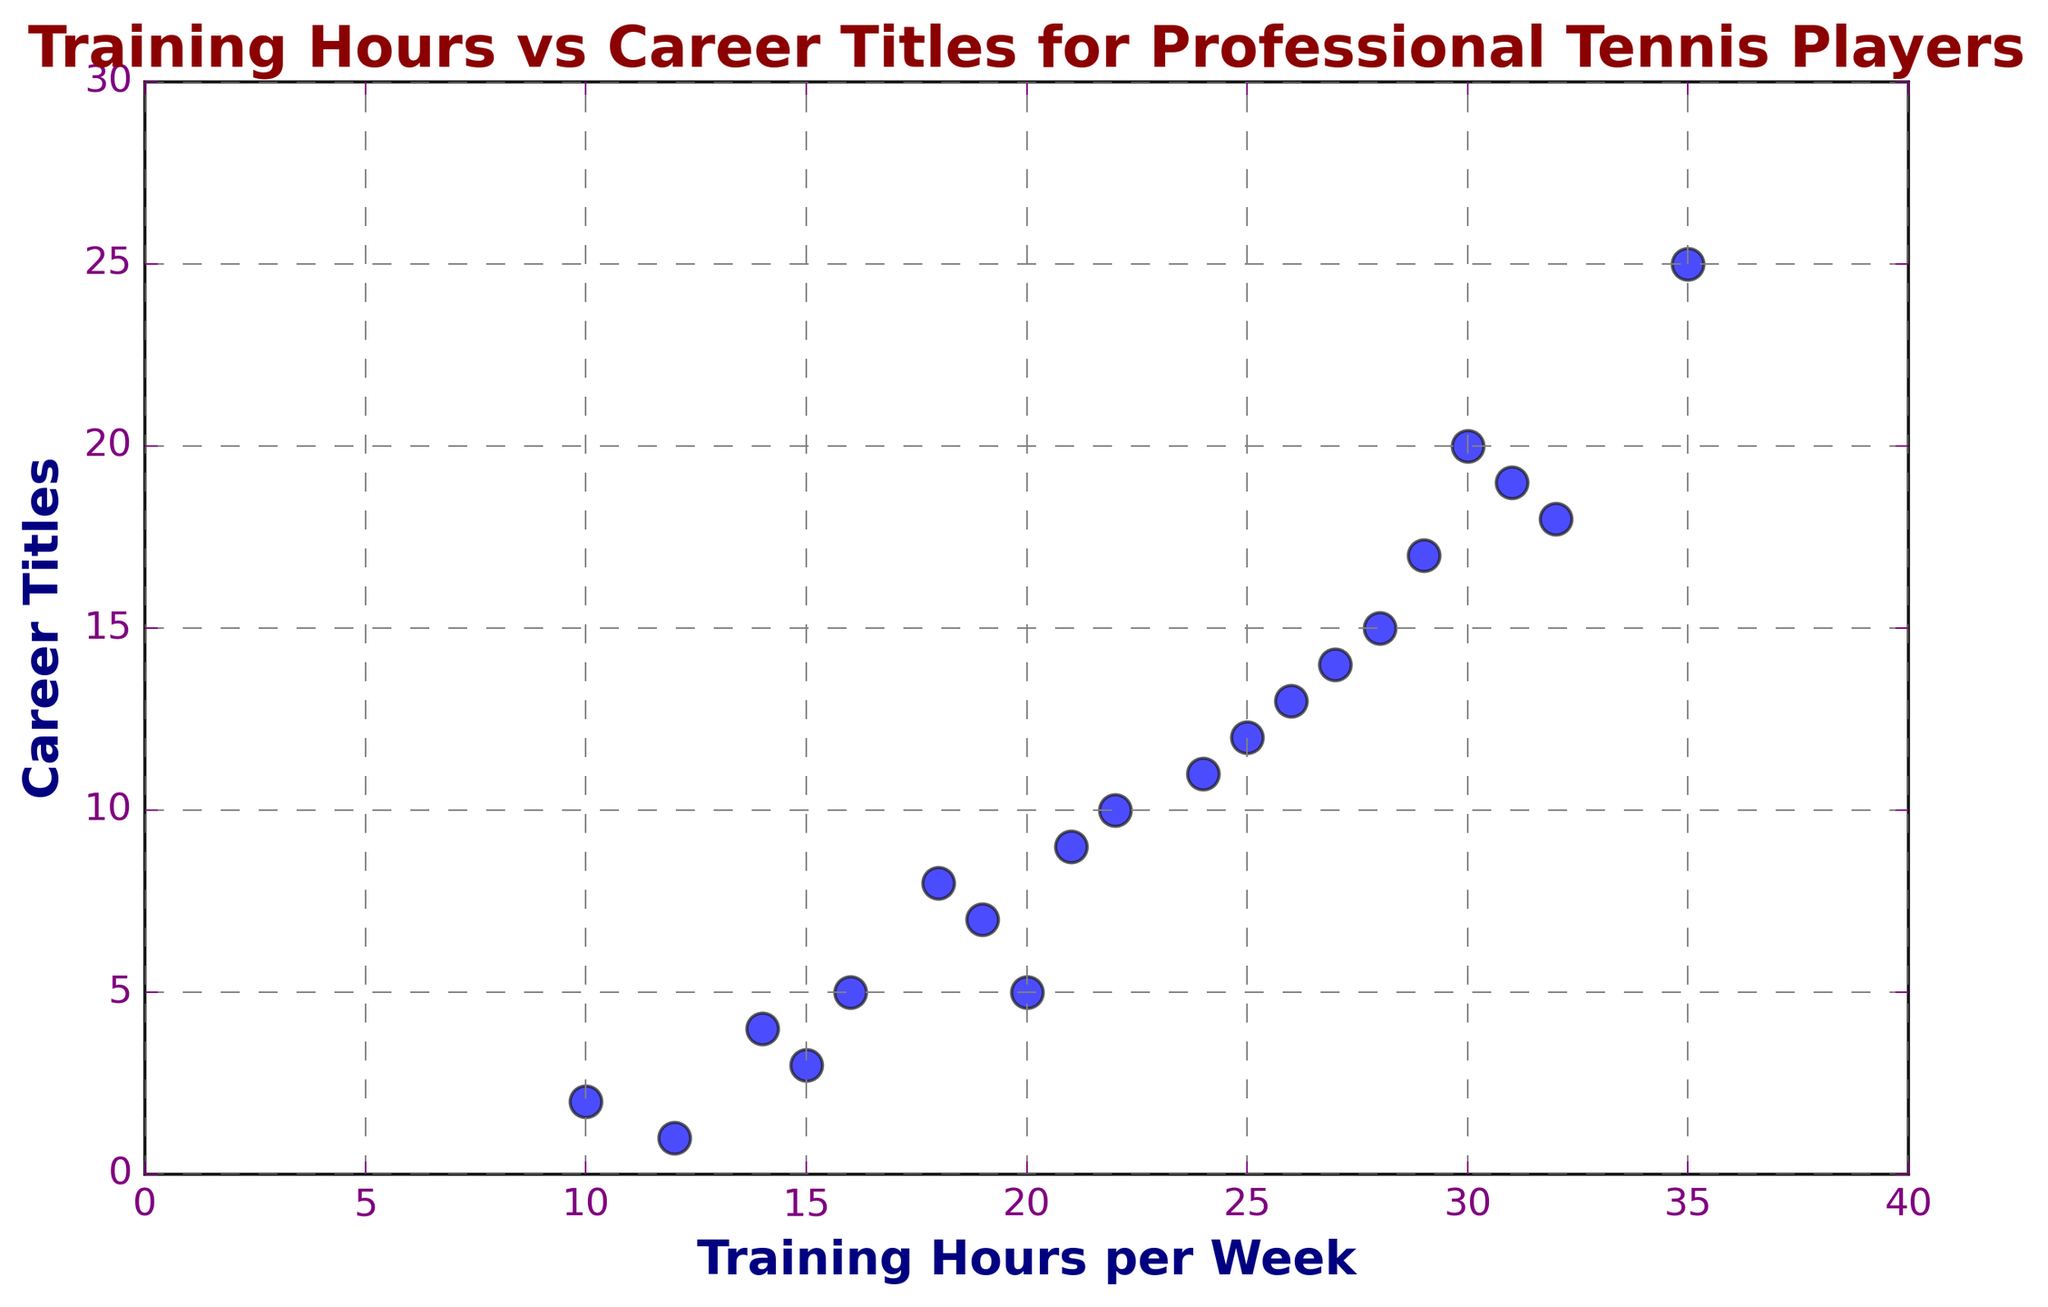What is the maximum number of career titles achieved by a player? The player with the highest number of career titles can be identified by looking at the highest point on the y-axis. The highest value for 'Career Titles' is 25.
Answer: 25 How many players train more than 25 hours per week? We can determine this by counting the number of points that are above 25 on the x-axis in the 'Training Hours per Week' dimension. There are 6 players (Player 6, Player 9, Player 11, Player 16, Player 19, and Player 20).
Answer: 6 Which player trains the least and how many hours do they train per week? The player with the lowest training hours per week is identified by looking at the smallest value on the x-axis. The lowest value is 10 hours, which corresponds to Player 5.
Answer: Player 5, 10 hours Is there a player who trains 30 hours per week? If so, how many career titles do they have? We look for a point where the x-axis value is 30 in the plot. The player (Player 4) who trains 30 hours per week has 20 career titles based on the y-axis value at that point.
Answer: 20 Which player has more career titles, the one who trains 22 hours per week or the one who trains 24 hours per week? By comparing the y-axis values of the points at x=22 hours (Player 8) and x=24 hours (Player 12), we see that the player training 22 hours per week has 10 titles and the player training 24 hours per week has 11 titles.
Answer: Player training 24 hours per week Calculate the average training hours per week for players with more than 10 career titles. Identify the training hours of players with more than 10 titles (Players: 2, 4, 6, 9, 11, 16, 17, 19, 20), sum these hours (25+30+35+28+26+32+27+29+31), then divide by the number of players (9). (25+30+35+28+26+32+27+29+31) / 9 = 263/9.
Answer: 29.22 hours How many career titles does the player with the median training hours have? First, list all training hours per week in ascending order (10, 12, 14, 15, 16, 18, 19, 20, 21, 22, 24, 25, 26, 27, 28, 29, 30, 31, 32, 35). The median value is the tenth value when n=20, which is 21 hours (Player 15), who has 9 career titles.
Answer: 9 Which player has the closest number of career titles to the average number of career titles? Calculate the average number of career titles (total titles: 15+17+18+19+20+25+12+3+5+2+1+13+11+4+7+9+5=166), then divide by number of players (20); the average is 8.3. Players with career titles close to 8.3 are Player 7 (8 titles) and Player 15 (9 titles).
Answer: Player 7, Player 15 Do any players with exactly 5 career titles train more than 15 hours per week? Look at the y-axis value of 5 career titles, then check the x-axis range. Players with 5 titles are Player 1 and Player 18, of which, Player 1 trains for 20 hours per week, which is more than 15.
Answer: Yes, Player 1 